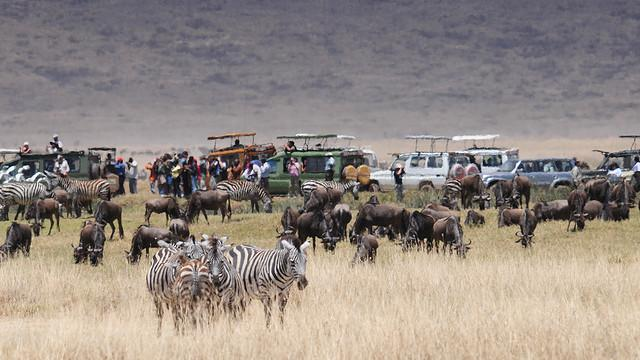What kind of animals are these in relation to their diets? Please explain your reasoning. herbivores. These animals are zebras and wildebeests. they have plant-based diets. 